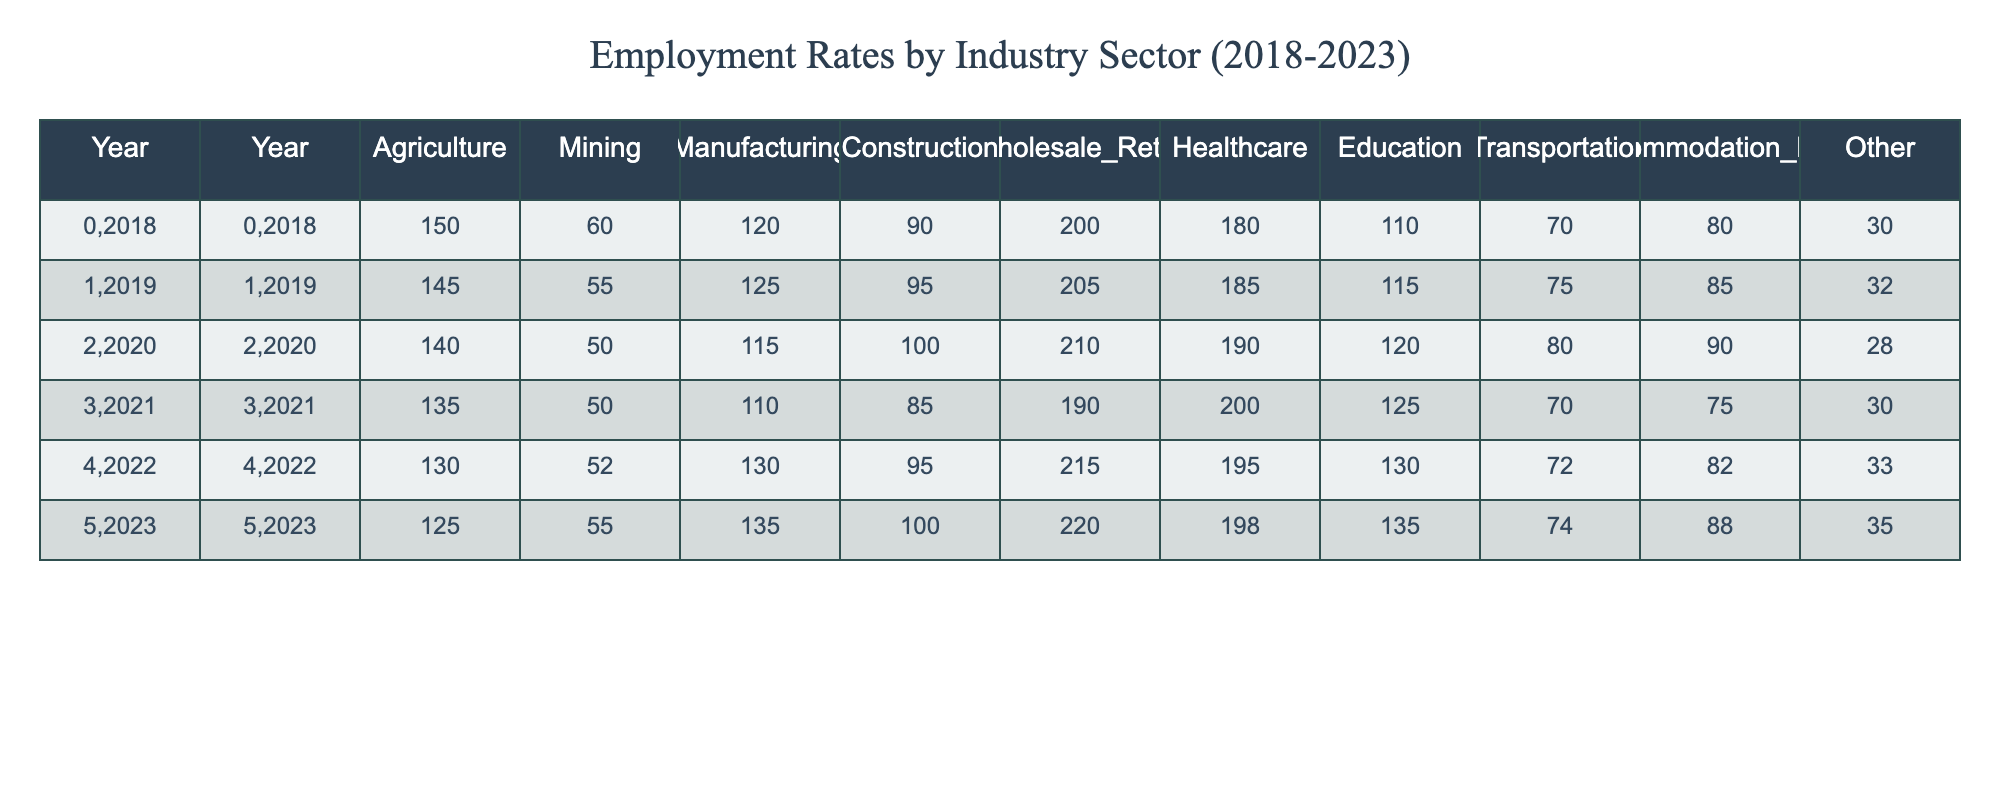What was the employment rate in the Healthcare sector in 2021? The table indicates that in 2021, the value for Healthcare is specifically listed under that year, which is 200.
Answer: 200 Which industry sector saw the largest increase in employment from 2018 to 2023? To identify the largest increase, we can compare the values for each sector across the years. By calculating the differences, we find that the Accommodation_Food sector increased from 80 to 88, an increase of 8. Other sectors have smaller increases or even declines. Therefore, Accommodation_Food has the largest increase.
Answer: Accommodation_Food Was there a decrease in employment for the Mining sector from 2018 to 2023? The values for the Mining sector over the years are 60 (2018) and 55 (2023). Since 55 is less than 60, this indicates a decrease.
Answer: Yes What was the total employment in the Construction sector over the 6 years? To find the total employment in the Construction sector, we need to sum the values for Construction from 2018 to 2023: (90 + 95 + 100 + 85 + 95 + 100) = 565.
Answer: 565 In 2022, which sector had the highest employment rate? By examining the values in the table for 2022, we see that Healthcare has a value of 195, which is the highest compared to other sectors like Agriculture (130), Mining (52), etc. Therefore, Healthcare had the highest employment rate in 2022.
Answer: Healthcare What is the average employment rate in the Wholesale_Retail sector over the years? First, we sum the values for Wholesale_Retail from 2018 to 2023: (200 + 205 + 210 + 190 + 215 + 220) = 1260. Then, divide by the number of years (6): 1260 / 6 = 210.
Answer: 210 Was the employment in the Education sector higher in 2023 than in 2019? The values are 135 for 2023 and 115 for 2019. Since 135 is greater than 115, this indicates that employment in Education was indeed higher in 2023 than in 2019.
Answer: Yes Which industry sectors had a consistent decline in employment from 2018 to 2023? Observing the table, we can see that Agriculture and Mining both showed a decline each year. For Agriculture: 150 to 125 and for Mining: 60 to 55. This confirms that both sectors experienced consistent decline.
Answer: Agriculture and Mining What is the difference in employment rates between the highest and lowest sectors for 2020? For 2020, the highest sector is Healthcare with 190, while the lowest is Mining with 50. The difference is calculated as 190 - 50 = 140.
Answer: 140 